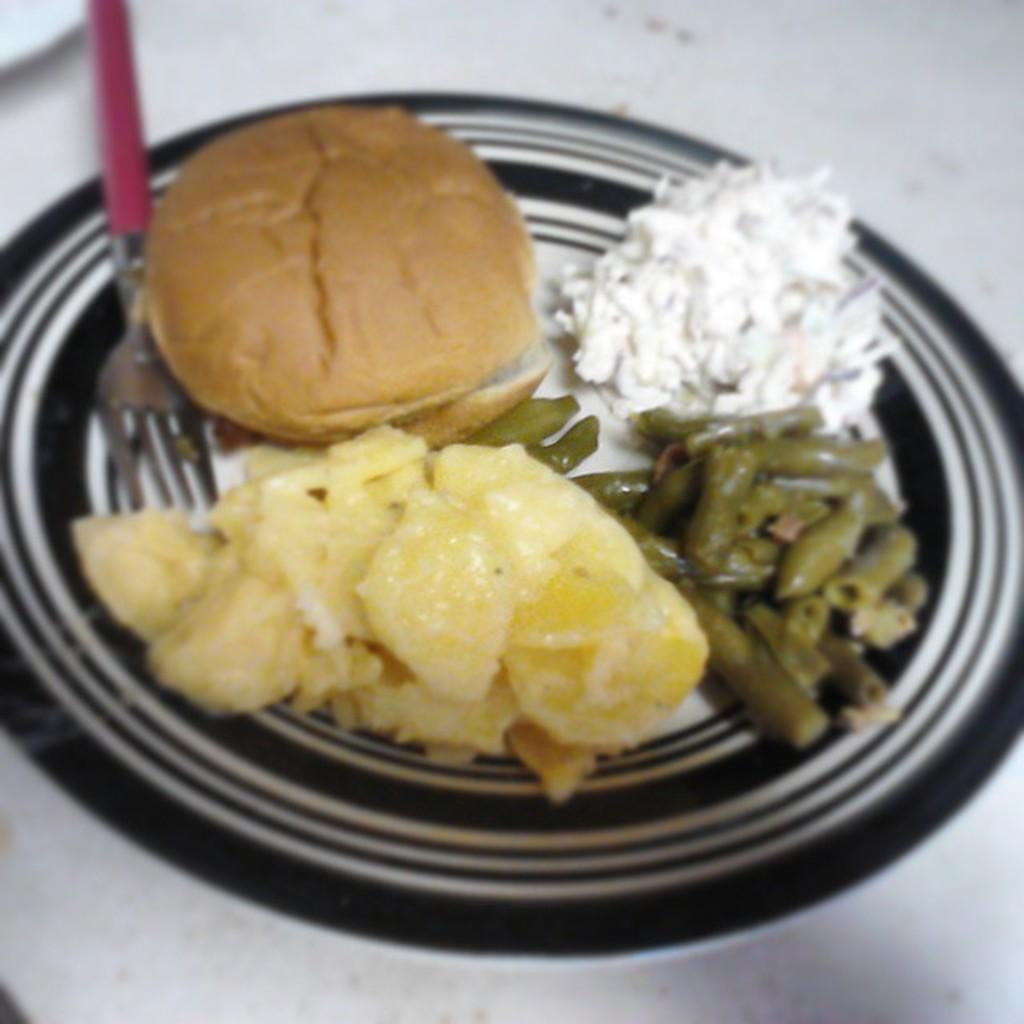What color is the table in the image? The table in the image is white. What is on top of the table? There is a black plate on the table. What is on the plate? There are food items in the plate. What utensil is present in the plate? There is a fork in the plate. What type of fuel is being used by the balloon in the image? There is no balloon present in the image, so it is not possible to determine what type of fuel it might be using. 